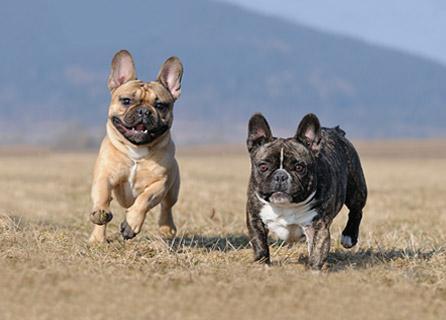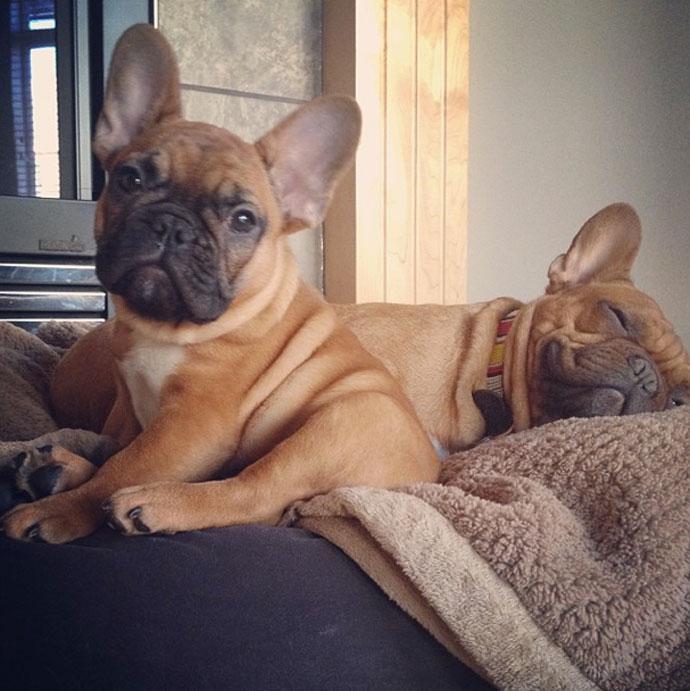The first image is the image on the left, the second image is the image on the right. For the images shown, is this caption "There are two french bull dogs laying on a bed." true? Answer yes or no. Yes. The first image is the image on the left, the second image is the image on the right. Examine the images to the left and right. Is the description "An image shows two tan-colored dogs lounging on a cushioned item." accurate? Answer yes or no. Yes. 